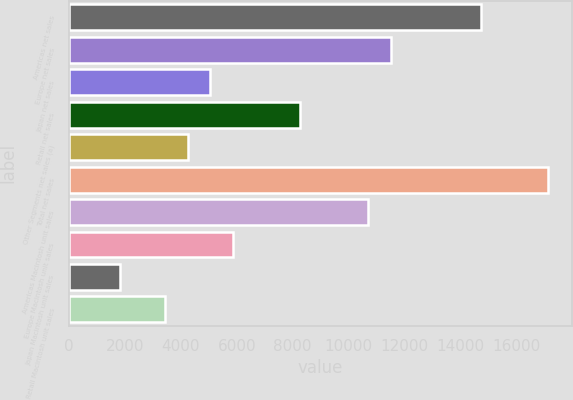Convert chart. <chart><loc_0><loc_0><loc_500><loc_500><bar_chart><fcel>Americas net sales<fcel>Europe net sales<fcel>Japan net sales<fcel>Retail net sales<fcel>Other Segments net sales (a)<fcel>Total net sales<fcel>Americas Macintosh unit sales<fcel>Europe Macintosh unit sales<fcel>Japan Macintosh unit sales<fcel>Retail Macintosh unit sales<nl><fcel>14718.2<fcel>11498.6<fcel>5059.4<fcel>8279<fcel>4254.5<fcel>17132.9<fcel>10693.7<fcel>5864.3<fcel>1839.8<fcel>3449.6<nl></chart> 